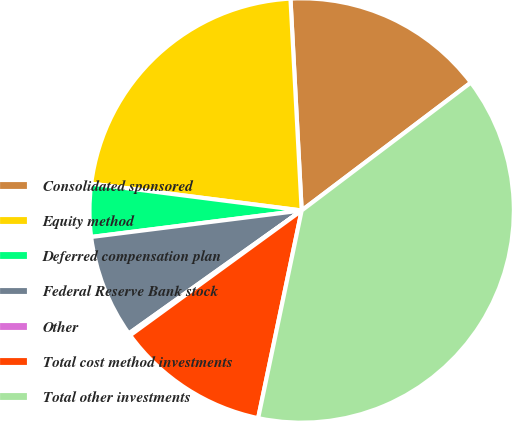Convert chart to OTSL. <chart><loc_0><loc_0><loc_500><loc_500><pie_chart><fcel>Consolidated sponsored<fcel>Equity method<fcel>Deferred compensation plan<fcel>Federal Reserve Bank stock<fcel>Other<fcel>Total cost method investments<fcel>Total other investments<nl><fcel>15.54%<fcel>22.14%<fcel>4.01%<fcel>7.85%<fcel>0.17%<fcel>11.7%<fcel>38.59%<nl></chart> 